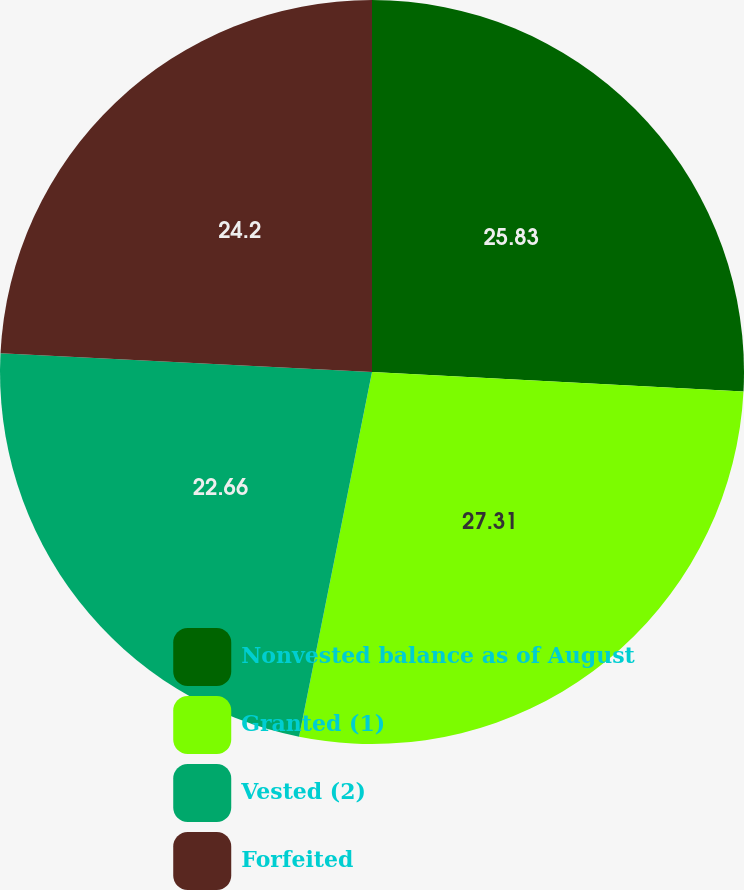<chart> <loc_0><loc_0><loc_500><loc_500><pie_chart><fcel>Nonvested balance as of August<fcel>Granted (1)<fcel>Vested (2)<fcel>Forfeited<nl><fcel>25.83%<fcel>27.31%<fcel>22.66%<fcel>24.2%<nl></chart> 